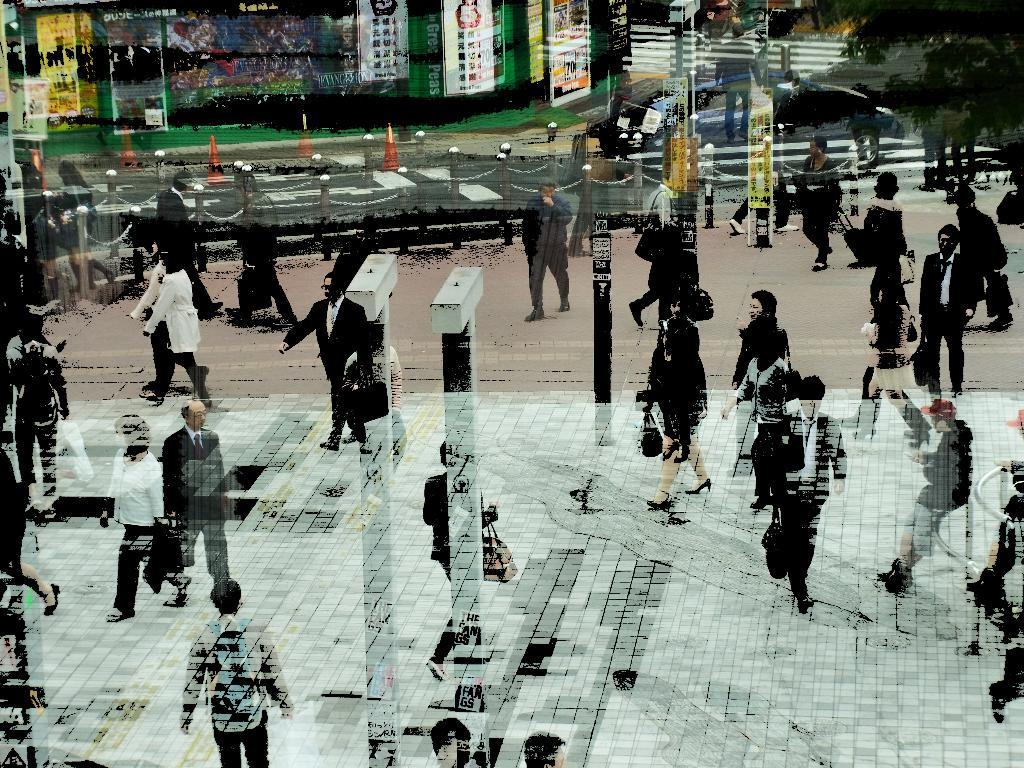How many people are in the image? There is a group of people in the image, but the exact number cannot be determined from the provided facts. What can be seen in the image besides the group of people? There are poles, a road, a chain, a traffic cone, banners, and a tree visible in the image. What might be used to control traffic in the image? The traffic cone in the image might be used to control traffic. What type of vegetation is present in the image? There is a tree in the image, which is a type of vegetation. What type of celery is being used to hold up the banners in the image? There is no celery present in the image; the banners are held up by poles. Can you describe the smiles on the faces of the people in the image? The provided facts do not mention any smiles on the faces of the people in the image. 